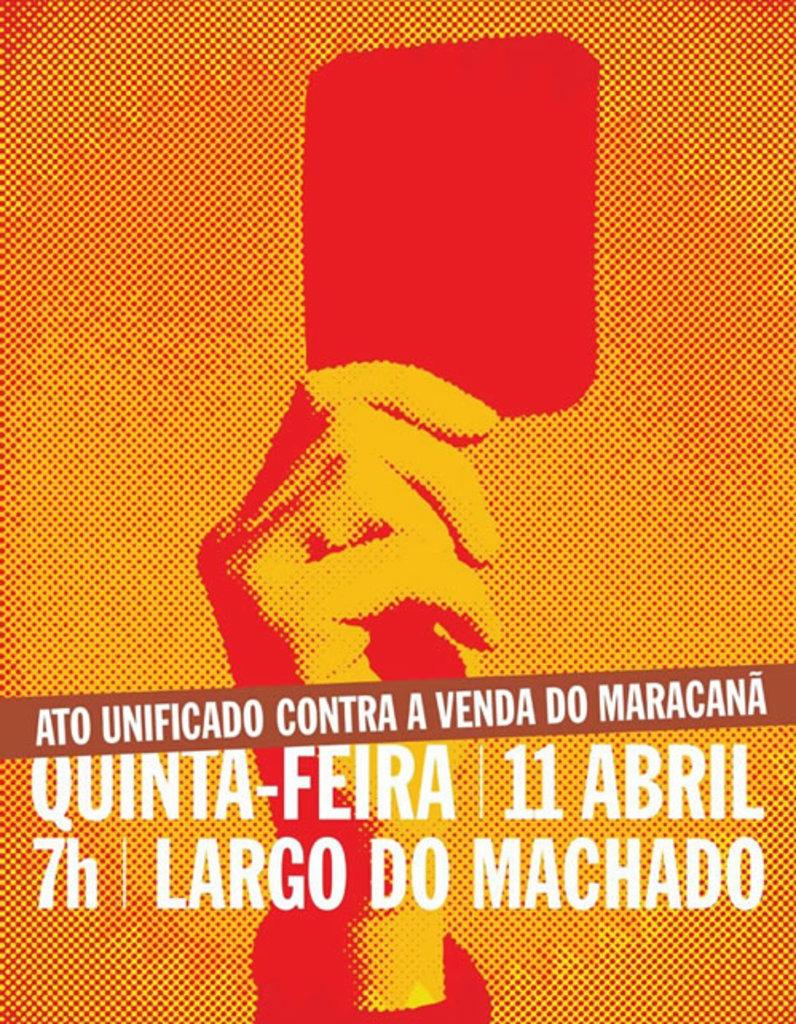What month is this event?
Your response must be concise. Abril. It is what day of april?
Your answer should be very brief. 11. 